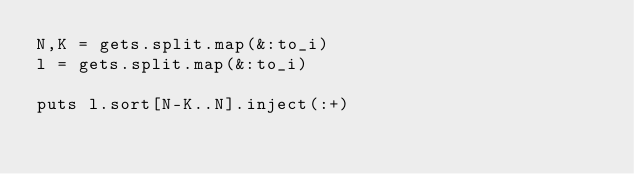<code> <loc_0><loc_0><loc_500><loc_500><_Ruby_>N,K = gets.split.map(&:to_i)
l = gets.split.map(&:to_i)

puts l.sort[N-K..N].inject(:+)</code> 